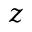Convert formula to latex. <formula><loc_0><loc_0><loc_500><loc_500>z</formula> 